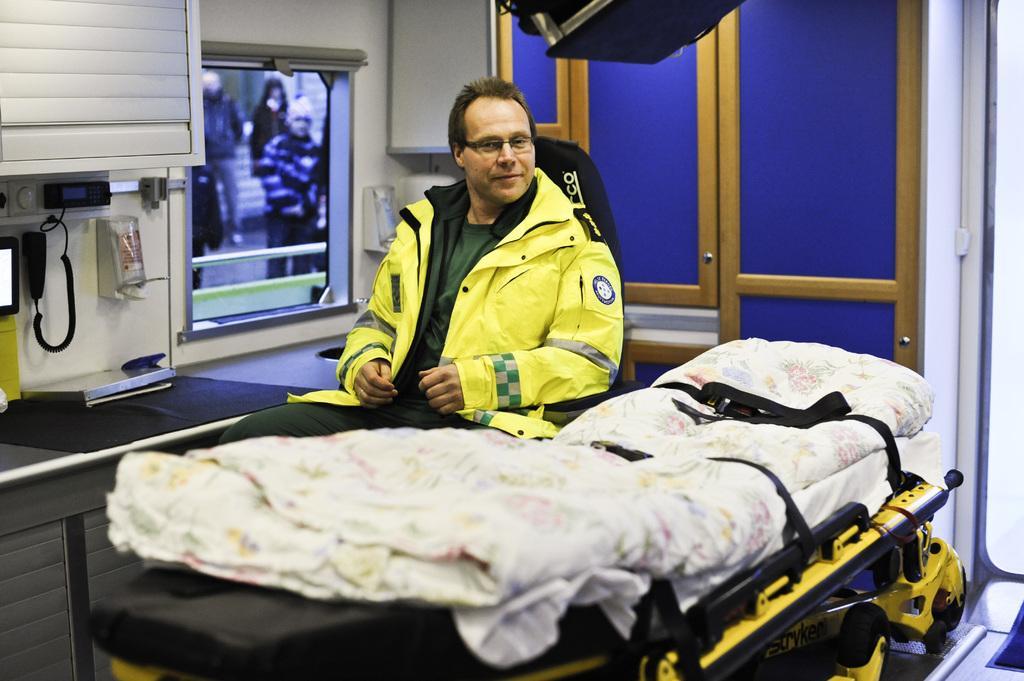How would you summarize this image in a sentence or two? In the center of the image, we can see a person wearing a coat and glasses and in the background, there is a bed sheet on the trolley and we can see doors, screen, telephone and some other objects are on the wall and there is a box on the table. At the top, there is a black color object. 